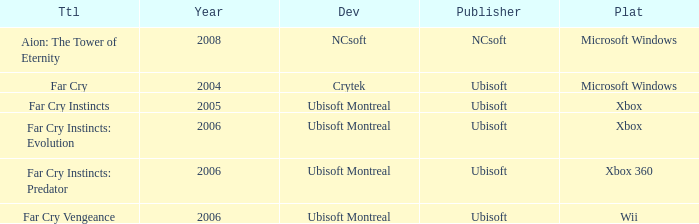Which developer has xbox 360 as the platform? Ubisoft Montreal. 